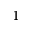<formula> <loc_0><loc_0><loc_500><loc_500>^ { 1 }</formula> 